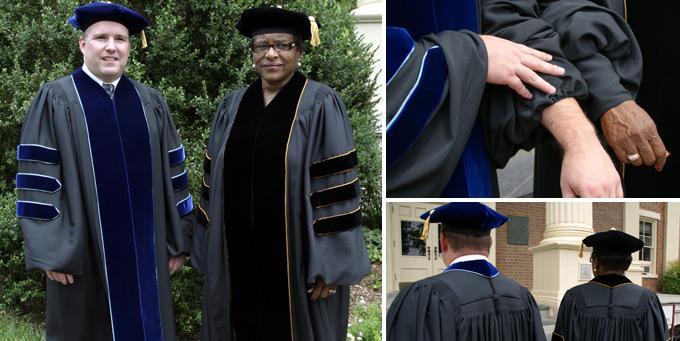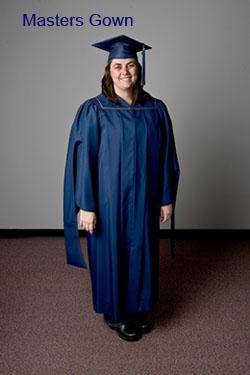The first image is the image on the left, the second image is the image on the right. Analyze the images presented: Is the assertion "There are at least 14 graduates and/or professors, and some of them are not wearing caps on their heads." valid? Answer yes or no. No. The first image is the image on the left, the second image is the image on the right. Examine the images to the left and right. Is the description "At least one person is holding a piece of paper." accurate? Answer yes or no. No. 